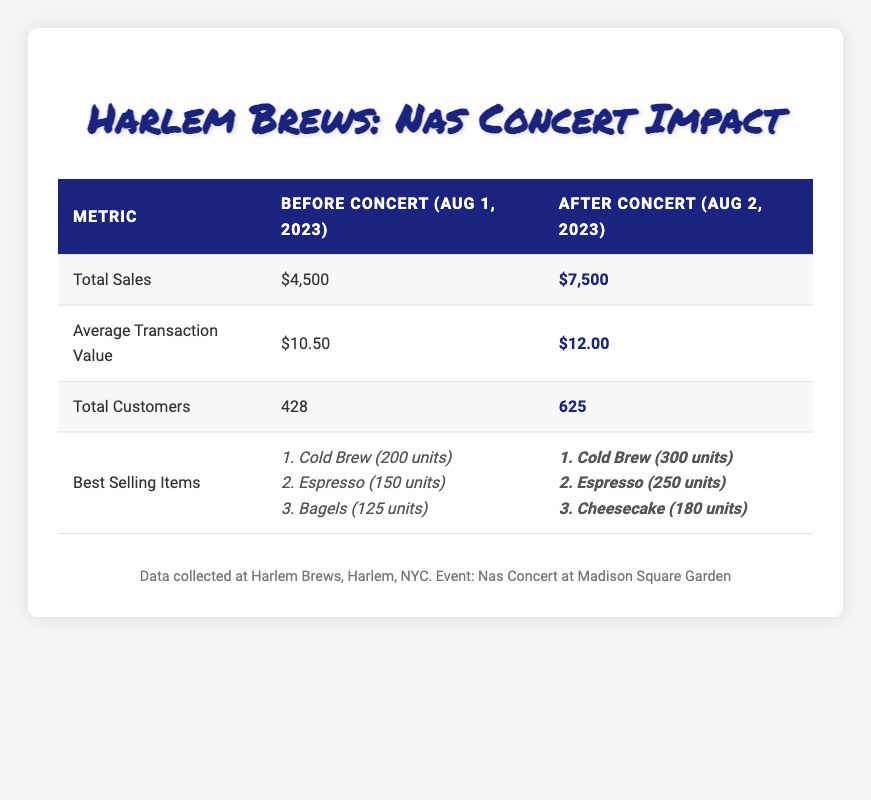What was the total sales for Harlem Brews before the concert? The "Total Sales" row in the "Before Concert" column states the total sales amount, which is $4,500.
Answer: $4,500 What was the average transaction value after the concert? The "Average Transaction Value" row in the "After Concert" column shows the value as $12.00.
Answer: $12.00 Did the number of customers increase after the concert? Comparing the "Total Customers" before the concert (428) and after the concert (625), there is an increase, as 625 is greater than 428.
Answer: Yes What was the total increase in sales from before to after the concert? The total sales before the concert were $4,500 and after were $7,500. To find the increase, subtract the before amount from the after amount: 7500 - 4500 = 3000.
Answer: $3,000 Which item had the highest sales before the concert? Looking at the "Best Selling Items" for "Before Concert," the "Cold Brew" with 200 units sold is the item with the highest sales.
Answer: Cold Brew How many more customers visited the coffee shop after the concert compared to before? The number of customers before the concert was 428 and after was 625. The difference is calculated by subtracting the before number from the after number: 625 - 428 = 197.
Answer: 197 What was the total number of best-selling items sold before the concert? To find the total best-selling items before the concert, add the units sold for all items: 200 (Cold Brew) + 150 (Espresso) + 125 (Bagels) = 475.
Answer: 475 Did Harlem Brews sell more units of Cheesecake before or after the concert? The best-selling items before the concert do not include Cheesecake, while after the concert it sold 180 units. This means they sold more units of Cheesecake after the concert.
Answer: After What percentage increase was seen in average transaction value after the concert? The average transaction value before was $10.50 and after was $12.00. The increase is 12.00 - 10.50 = 1.50. To find the percentage increase: (1.50 / 10.50) * 100 ≈ 14.29%.
Answer: Approximately 14.29% 